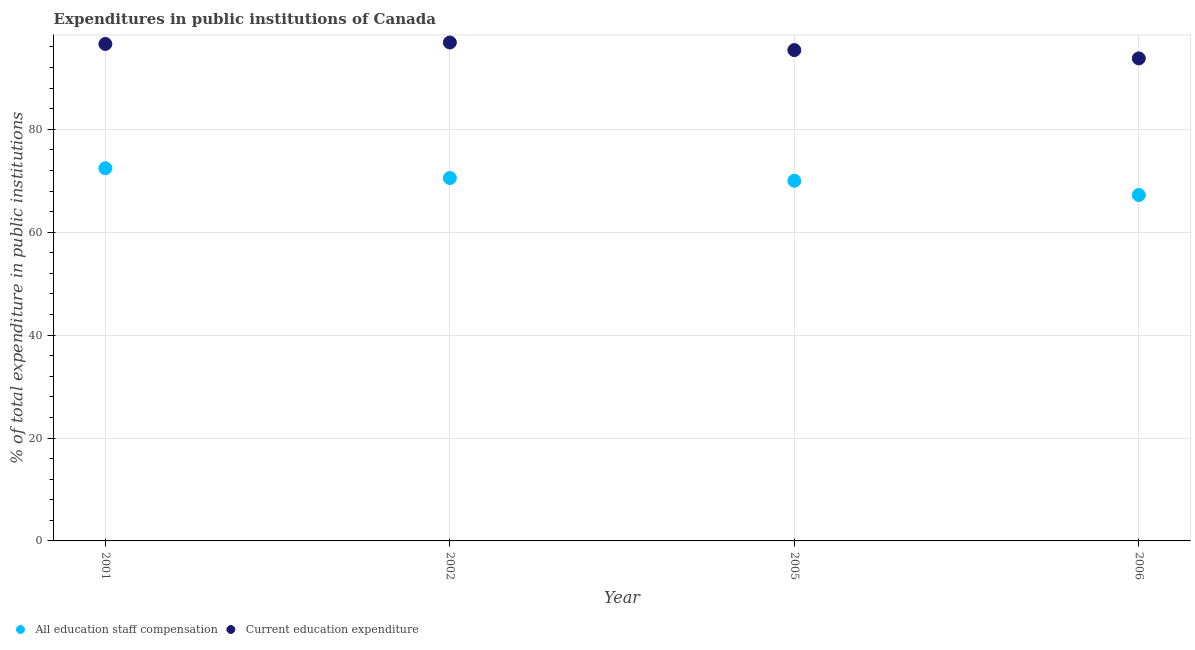How many different coloured dotlines are there?
Give a very brief answer. 2. What is the expenditure in education in 2006?
Provide a succinct answer. 93.78. Across all years, what is the maximum expenditure in education?
Give a very brief answer. 96.87. Across all years, what is the minimum expenditure in staff compensation?
Ensure brevity in your answer.  67.23. In which year was the expenditure in education maximum?
Your answer should be compact. 2002. What is the total expenditure in staff compensation in the graph?
Ensure brevity in your answer.  280.19. What is the difference between the expenditure in staff compensation in 2001 and that in 2005?
Your answer should be compact. 2.43. What is the difference between the expenditure in education in 2001 and the expenditure in staff compensation in 2002?
Keep it short and to the point. 26.06. What is the average expenditure in education per year?
Your answer should be very brief. 95.66. In the year 2005, what is the difference between the expenditure in staff compensation and expenditure in education?
Your answer should be very brief. -25.39. In how many years, is the expenditure in education greater than 24 %?
Provide a short and direct response. 4. What is the ratio of the expenditure in staff compensation in 2001 to that in 2006?
Provide a short and direct response. 1.08. What is the difference between the highest and the second highest expenditure in staff compensation?
Provide a short and direct response. 1.9. What is the difference between the highest and the lowest expenditure in staff compensation?
Keep it short and to the point. 5.2. In how many years, is the expenditure in staff compensation greater than the average expenditure in staff compensation taken over all years?
Provide a short and direct response. 2. Does the expenditure in staff compensation monotonically increase over the years?
Give a very brief answer. No. Is the expenditure in staff compensation strictly greater than the expenditure in education over the years?
Make the answer very short. No. Is the expenditure in education strictly less than the expenditure in staff compensation over the years?
Give a very brief answer. No. Are the values on the major ticks of Y-axis written in scientific E-notation?
Make the answer very short. No. Does the graph contain grids?
Offer a very short reply. Yes. How many legend labels are there?
Offer a very short reply. 2. How are the legend labels stacked?
Your response must be concise. Horizontal. What is the title of the graph?
Make the answer very short. Expenditures in public institutions of Canada. Does "By country of origin" appear as one of the legend labels in the graph?
Give a very brief answer. No. What is the label or title of the Y-axis?
Provide a short and direct response. % of total expenditure in public institutions. What is the % of total expenditure in public institutions of All education staff compensation in 2001?
Your answer should be very brief. 72.43. What is the % of total expenditure in public institutions in Current education expenditure in 2001?
Your answer should be compact. 96.59. What is the % of total expenditure in public institutions in All education staff compensation in 2002?
Give a very brief answer. 70.53. What is the % of total expenditure in public institutions in Current education expenditure in 2002?
Your response must be concise. 96.87. What is the % of total expenditure in public institutions of All education staff compensation in 2005?
Ensure brevity in your answer.  70. What is the % of total expenditure in public institutions of Current education expenditure in 2005?
Keep it short and to the point. 95.39. What is the % of total expenditure in public institutions of All education staff compensation in 2006?
Make the answer very short. 67.23. What is the % of total expenditure in public institutions in Current education expenditure in 2006?
Provide a short and direct response. 93.78. Across all years, what is the maximum % of total expenditure in public institutions of All education staff compensation?
Make the answer very short. 72.43. Across all years, what is the maximum % of total expenditure in public institutions of Current education expenditure?
Keep it short and to the point. 96.87. Across all years, what is the minimum % of total expenditure in public institutions in All education staff compensation?
Offer a terse response. 67.23. Across all years, what is the minimum % of total expenditure in public institutions of Current education expenditure?
Provide a short and direct response. 93.78. What is the total % of total expenditure in public institutions of All education staff compensation in the graph?
Your answer should be compact. 280.19. What is the total % of total expenditure in public institutions of Current education expenditure in the graph?
Your answer should be very brief. 382.63. What is the difference between the % of total expenditure in public institutions of All education staff compensation in 2001 and that in 2002?
Your response must be concise. 1.9. What is the difference between the % of total expenditure in public institutions in Current education expenditure in 2001 and that in 2002?
Your answer should be compact. -0.28. What is the difference between the % of total expenditure in public institutions in All education staff compensation in 2001 and that in 2005?
Make the answer very short. 2.43. What is the difference between the % of total expenditure in public institutions of Current education expenditure in 2001 and that in 2005?
Your answer should be very brief. 1.19. What is the difference between the % of total expenditure in public institutions in All education staff compensation in 2001 and that in 2006?
Your answer should be very brief. 5.2. What is the difference between the % of total expenditure in public institutions of Current education expenditure in 2001 and that in 2006?
Your answer should be very brief. 2.81. What is the difference between the % of total expenditure in public institutions of All education staff compensation in 2002 and that in 2005?
Give a very brief answer. 0.53. What is the difference between the % of total expenditure in public institutions of Current education expenditure in 2002 and that in 2005?
Offer a very short reply. 1.48. What is the difference between the % of total expenditure in public institutions of All education staff compensation in 2002 and that in 2006?
Keep it short and to the point. 3.3. What is the difference between the % of total expenditure in public institutions in Current education expenditure in 2002 and that in 2006?
Provide a short and direct response. 3.09. What is the difference between the % of total expenditure in public institutions in All education staff compensation in 2005 and that in 2006?
Provide a short and direct response. 2.77. What is the difference between the % of total expenditure in public institutions of Current education expenditure in 2005 and that in 2006?
Offer a very short reply. 1.61. What is the difference between the % of total expenditure in public institutions in All education staff compensation in 2001 and the % of total expenditure in public institutions in Current education expenditure in 2002?
Offer a very short reply. -24.44. What is the difference between the % of total expenditure in public institutions in All education staff compensation in 2001 and the % of total expenditure in public institutions in Current education expenditure in 2005?
Give a very brief answer. -22.96. What is the difference between the % of total expenditure in public institutions of All education staff compensation in 2001 and the % of total expenditure in public institutions of Current education expenditure in 2006?
Ensure brevity in your answer.  -21.35. What is the difference between the % of total expenditure in public institutions of All education staff compensation in 2002 and the % of total expenditure in public institutions of Current education expenditure in 2005?
Give a very brief answer. -24.86. What is the difference between the % of total expenditure in public institutions in All education staff compensation in 2002 and the % of total expenditure in public institutions in Current education expenditure in 2006?
Give a very brief answer. -23.25. What is the difference between the % of total expenditure in public institutions of All education staff compensation in 2005 and the % of total expenditure in public institutions of Current education expenditure in 2006?
Ensure brevity in your answer.  -23.78. What is the average % of total expenditure in public institutions of All education staff compensation per year?
Provide a short and direct response. 70.05. What is the average % of total expenditure in public institutions in Current education expenditure per year?
Make the answer very short. 95.66. In the year 2001, what is the difference between the % of total expenditure in public institutions in All education staff compensation and % of total expenditure in public institutions in Current education expenditure?
Your answer should be very brief. -24.15. In the year 2002, what is the difference between the % of total expenditure in public institutions in All education staff compensation and % of total expenditure in public institutions in Current education expenditure?
Provide a succinct answer. -26.34. In the year 2005, what is the difference between the % of total expenditure in public institutions of All education staff compensation and % of total expenditure in public institutions of Current education expenditure?
Offer a very short reply. -25.39. In the year 2006, what is the difference between the % of total expenditure in public institutions in All education staff compensation and % of total expenditure in public institutions in Current education expenditure?
Offer a terse response. -26.55. What is the ratio of the % of total expenditure in public institutions in All education staff compensation in 2001 to that in 2005?
Make the answer very short. 1.03. What is the ratio of the % of total expenditure in public institutions in Current education expenditure in 2001 to that in 2005?
Provide a short and direct response. 1.01. What is the ratio of the % of total expenditure in public institutions in All education staff compensation in 2001 to that in 2006?
Provide a short and direct response. 1.08. What is the ratio of the % of total expenditure in public institutions of Current education expenditure in 2001 to that in 2006?
Your answer should be very brief. 1.03. What is the ratio of the % of total expenditure in public institutions in All education staff compensation in 2002 to that in 2005?
Offer a terse response. 1.01. What is the ratio of the % of total expenditure in public institutions of Current education expenditure in 2002 to that in 2005?
Your response must be concise. 1.02. What is the ratio of the % of total expenditure in public institutions in All education staff compensation in 2002 to that in 2006?
Your answer should be compact. 1.05. What is the ratio of the % of total expenditure in public institutions of Current education expenditure in 2002 to that in 2006?
Your answer should be very brief. 1.03. What is the ratio of the % of total expenditure in public institutions of All education staff compensation in 2005 to that in 2006?
Your response must be concise. 1.04. What is the ratio of the % of total expenditure in public institutions in Current education expenditure in 2005 to that in 2006?
Your response must be concise. 1.02. What is the difference between the highest and the second highest % of total expenditure in public institutions of All education staff compensation?
Your answer should be very brief. 1.9. What is the difference between the highest and the second highest % of total expenditure in public institutions in Current education expenditure?
Ensure brevity in your answer.  0.28. What is the difference between the highest and the lowest % of total expenditure in public institutions of All education staff compensation?
Provide a short and direct response. 5.2. What is the difference between the highest and the lowest % of total expenditure in public institutions of Current education expenditure?
Provide a succinct answer. 3.09. 